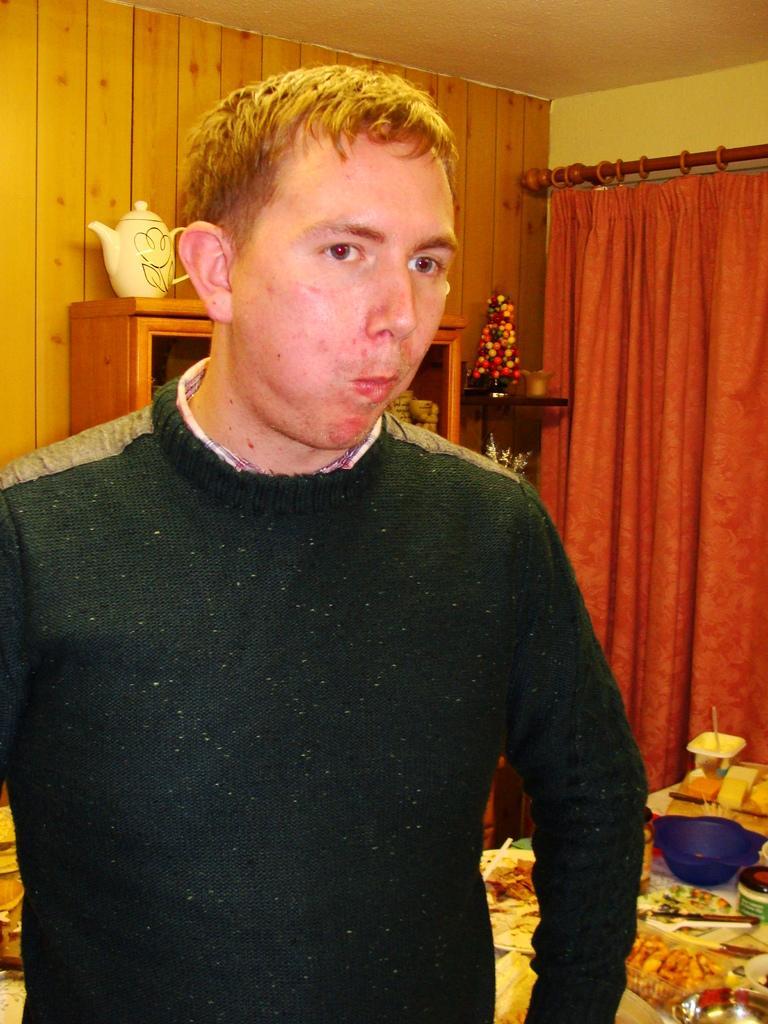Describe this image in one or two sentences. This is the man standing. He wore a sweater. This looks like a wooden rack. I can see a kettle, which is placed above the wooden rack. I can see a table with a bowl, knife, plate and few other things on it. This is a curtain hanging to the hanger. 